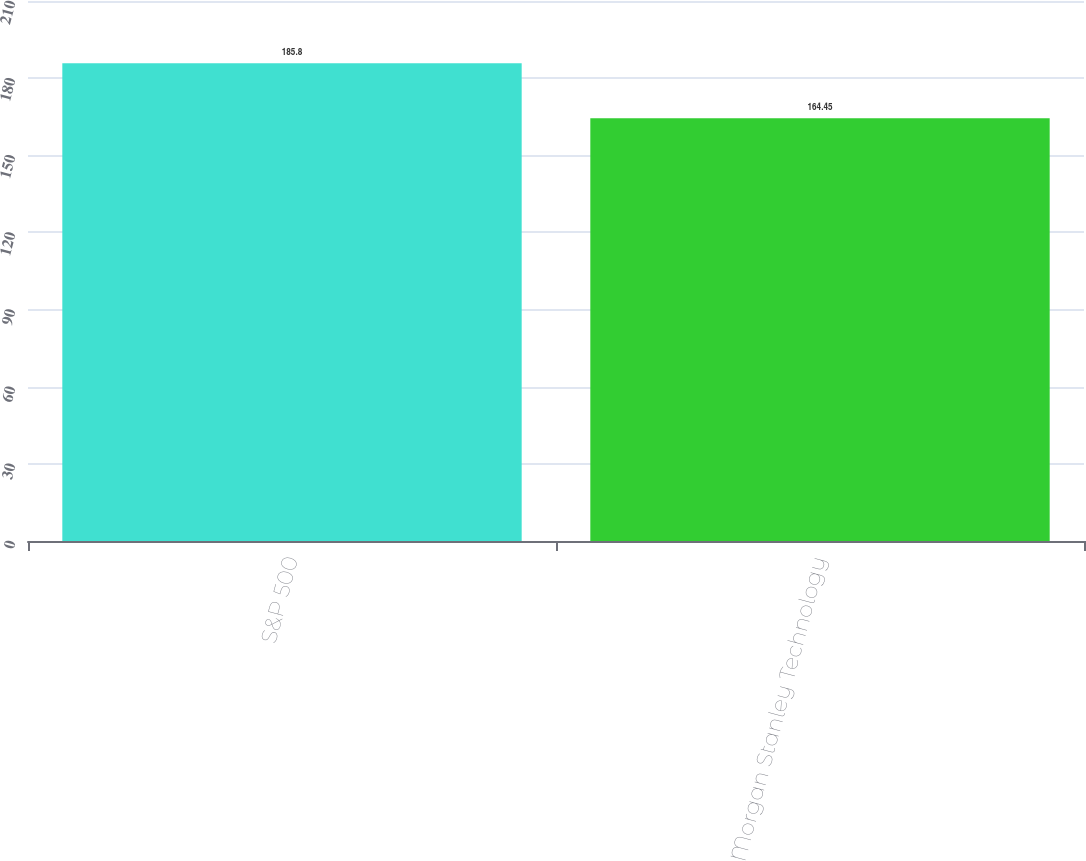<chart> <loc_0><loc_0><loc_500><loc_500><bar_chart><fcel>S&P 500<fcel>Morgan Stanley Technology<nl><fcel>185.8<fcel>164.45<nl></chart> 